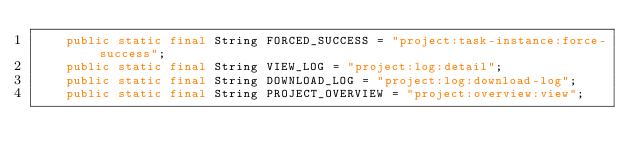Convert code to text. <code><loc_0><loc_0><loc_500><loc_500><_Java_>    public static final String FORCED_SUCCESS = "project:task-instance:force-success";
    public static final String VIEW_LOG = "project:log:detail";
    public static final String DOWNLOAD_LOG = "project:log:download-log";
    public static final String PROJECT_OVERVIEW = "project:overview:view";</code> 